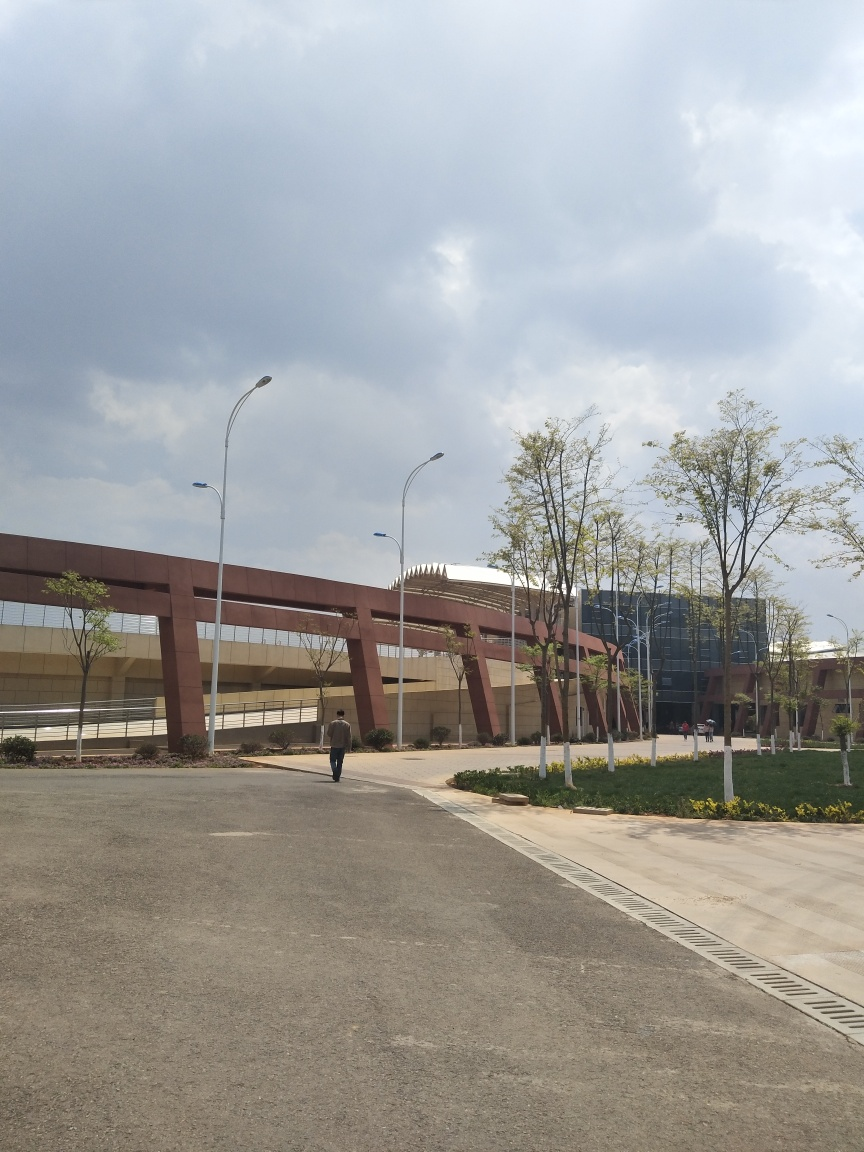What time of day does this photo appear to be taken? The long shadows and the quality of the light suggest that the photo was taken either in the early morning or late afternoon, a time often referred to as the golden hour, which gives a warm and soft quality to the light. 